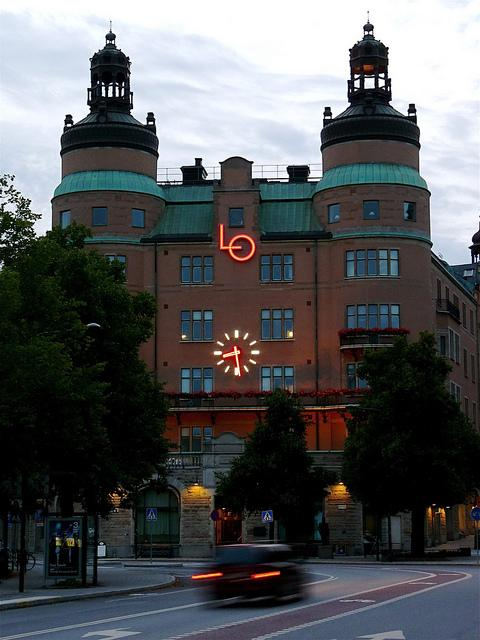What gas causes these lights to glow? neon 